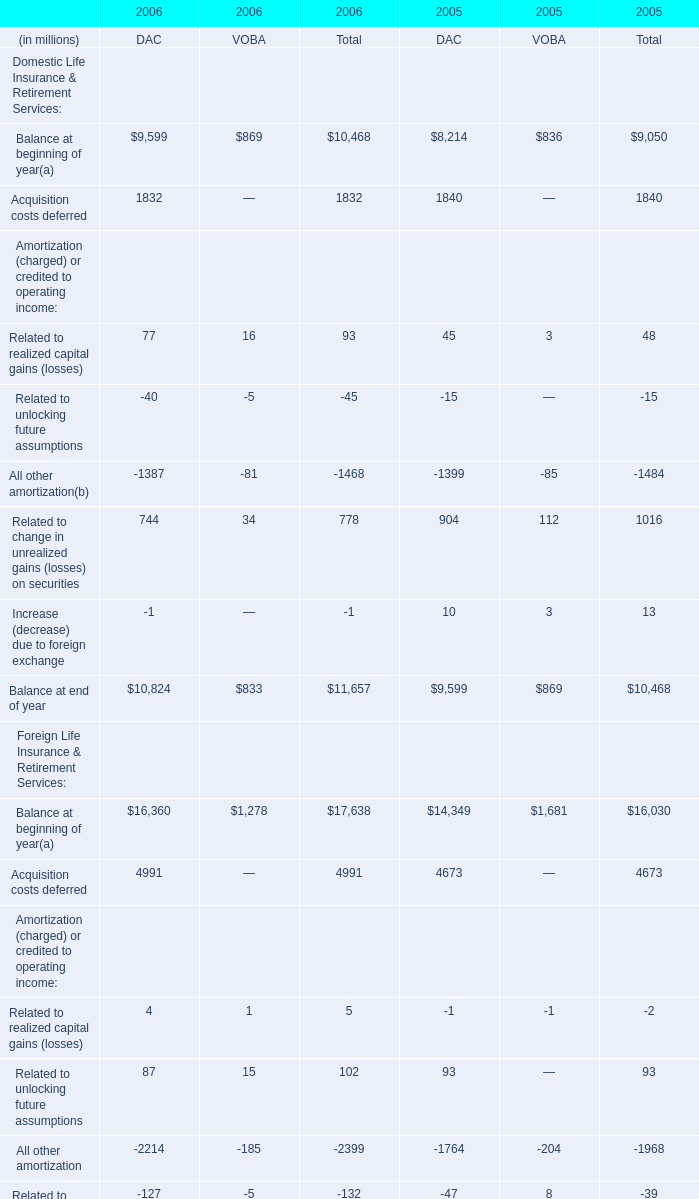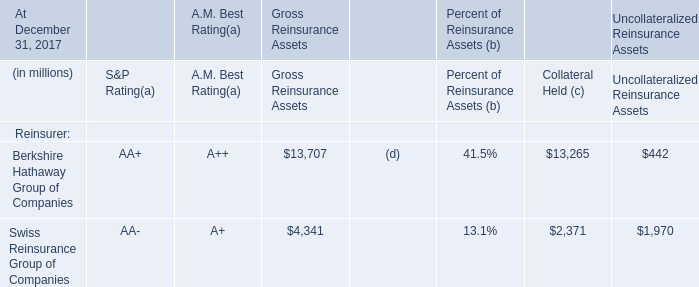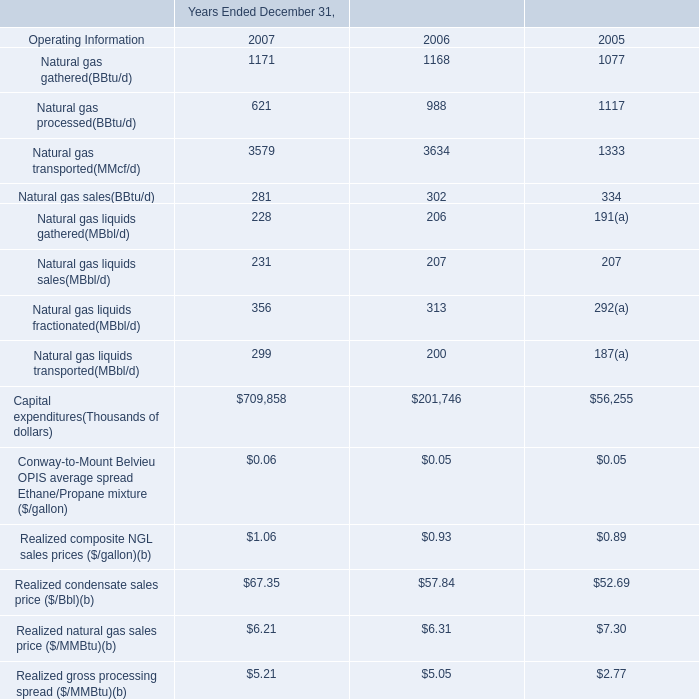Which year is Foreign Life Insurance & Retirement Services: Acquisition costs deferred the highest? 
Answer: 2006. 